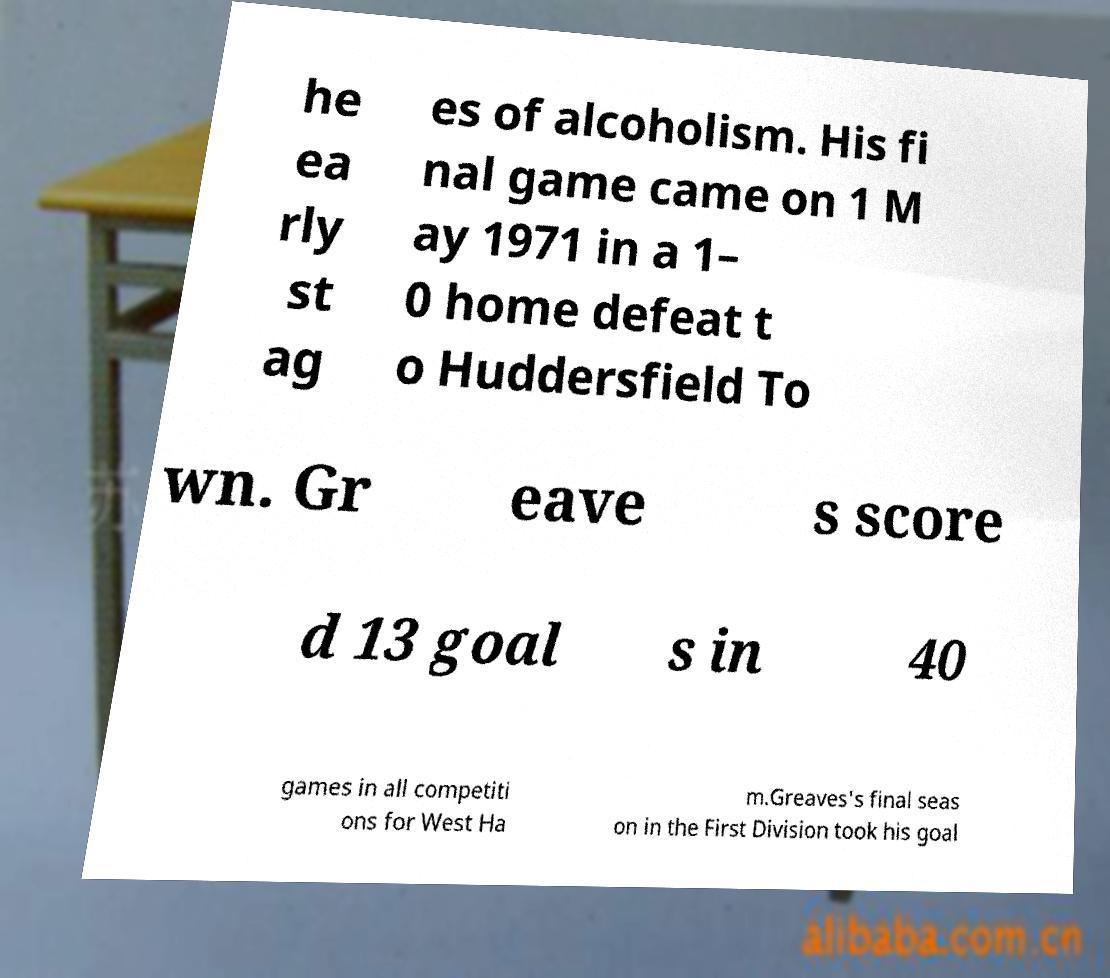For documentation purposes, I need the text within this image transcribed. Could you provide that? he ea rly st ag es of alcoholism. His fi nal game came on 1 M ay 1971 in a 1– 0 home defeat t o Huddersfield To wn. Gr eave s score d 13 goal s in 40 games in all competiti ons for West Ha m.Greaves's final seas on in the First Division took his goal 